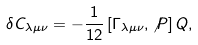<formula> <loc_0><loc_0><loc_500><loc_500>\delta C _ { \lambda \mu \nu } = - \frac { 1 } { 1 2 } \left [ \Gamma _ { \lambda \mu \nu } , \not P \right ] Q ,</formula> 